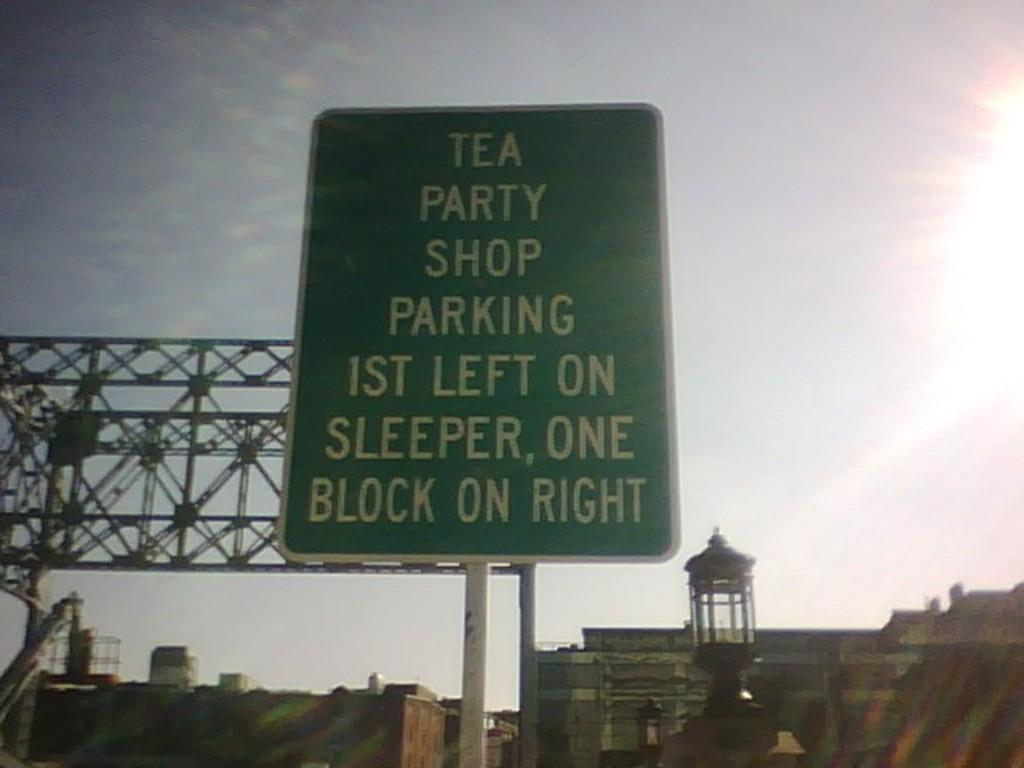<image>
Render a clear and concise summary of the photo. A green sign about Tea Party Shop parking tells people where to go. 